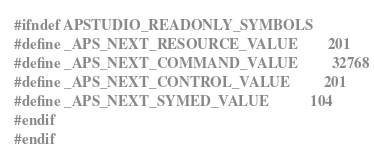<code> <loc_0><loc_0><loc_500><loc_500><_C_>#ifndef APSTUDIO_READONLY_SYMBOLS
#define _APS_NEXT_RESOURCE_VALUE        201
#define _APS_NEXT_COMMAND_VALUE         32768
#define _APS_NEXT_CONTROL_VALUE         201
#define _APS_NEXT_SYMED_VALUE           104
#endif
#endif
</code> 